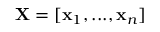Convert formula to latex. <formula><loc_0><loc_0><loc_500><loc_500>\mathbf X = [ \mathbf x _ { 1 } , \dots , \mathbf x _ { n } ]</formula> 